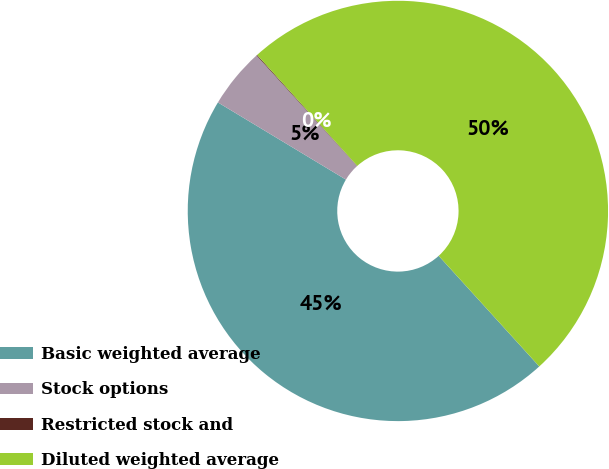Convert chart. <chart><loc_0><loc_0><loc_500><loc_500><pie_chart><fcel>Basic weighted average<fcel>Stock options<fcel>Restricted stock and<fcel>Diluted weighted average<nl><fcel>45.38%<fcel>4.62%<fcel>0.06%<fcel>49.94%<nl></chart> 